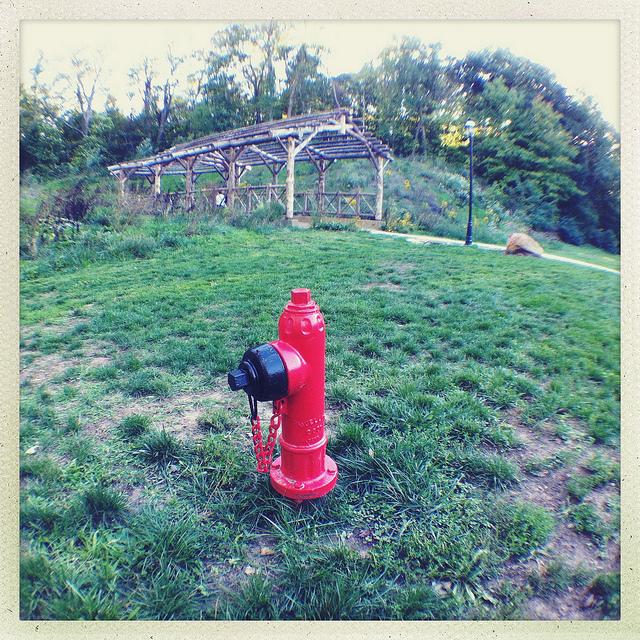Is that a covered bridge?
Short answer required. Yes. What is the red object?
Give a very brief answer. Fire hydrant. Is the bridge broke?
Keep it brief. No. 